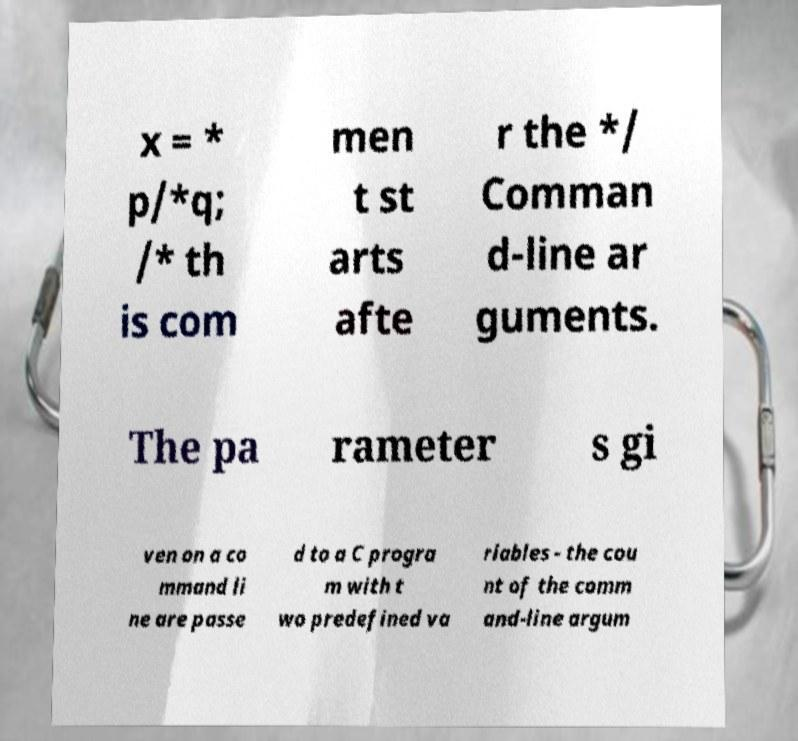Please read and relay the text visible in this image. What does it say? x = * p/*q; /* th is com men t st arts afte r the */ Comman d-line ar guments. The pa rameter s gi ven on a co mmand li ne are passe d to a C progra m with t wo predefined va riables - the cou nt of the comm and-line argum 